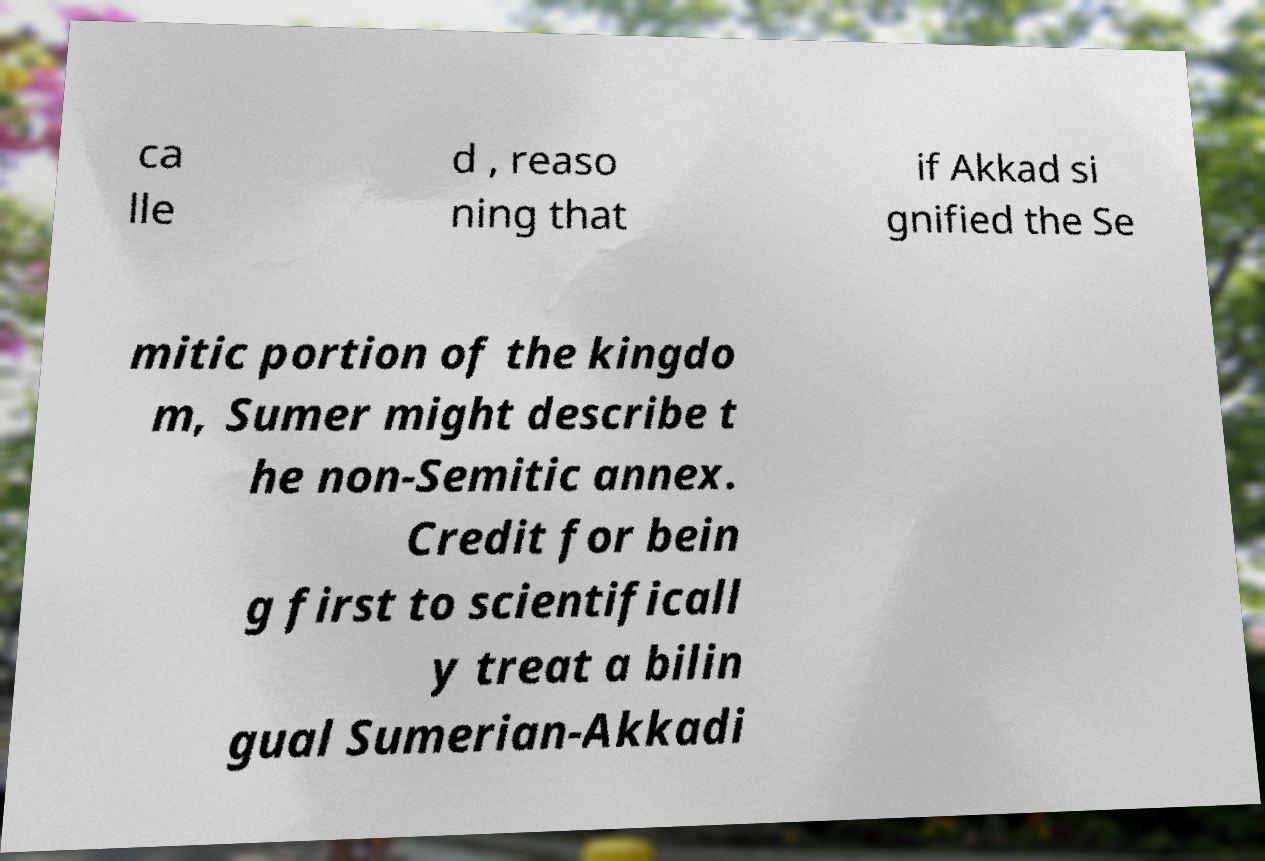Could you assist in decoding the text presented in this image and type it out clearly? ca lle d , reaso ning that if Akkad si gnified the Se mitic portion of the kingdo m, Sumer might describe t he non-Semitic annex. Credit for bein g first to scientificall y treat a bilin gual Sumerian-Akkadi 